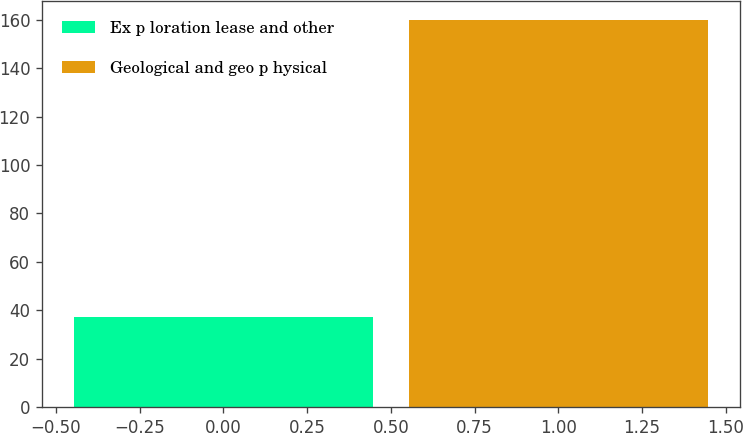Convert chart to OTSL. <chart><loc_0><loc_0><loc_500><loc_500><bar_chart><fcel>Ex p loration lease and other<fcel>Geological and geo p hysical<nl><fcel>37<fcel>160<nl></chart> 